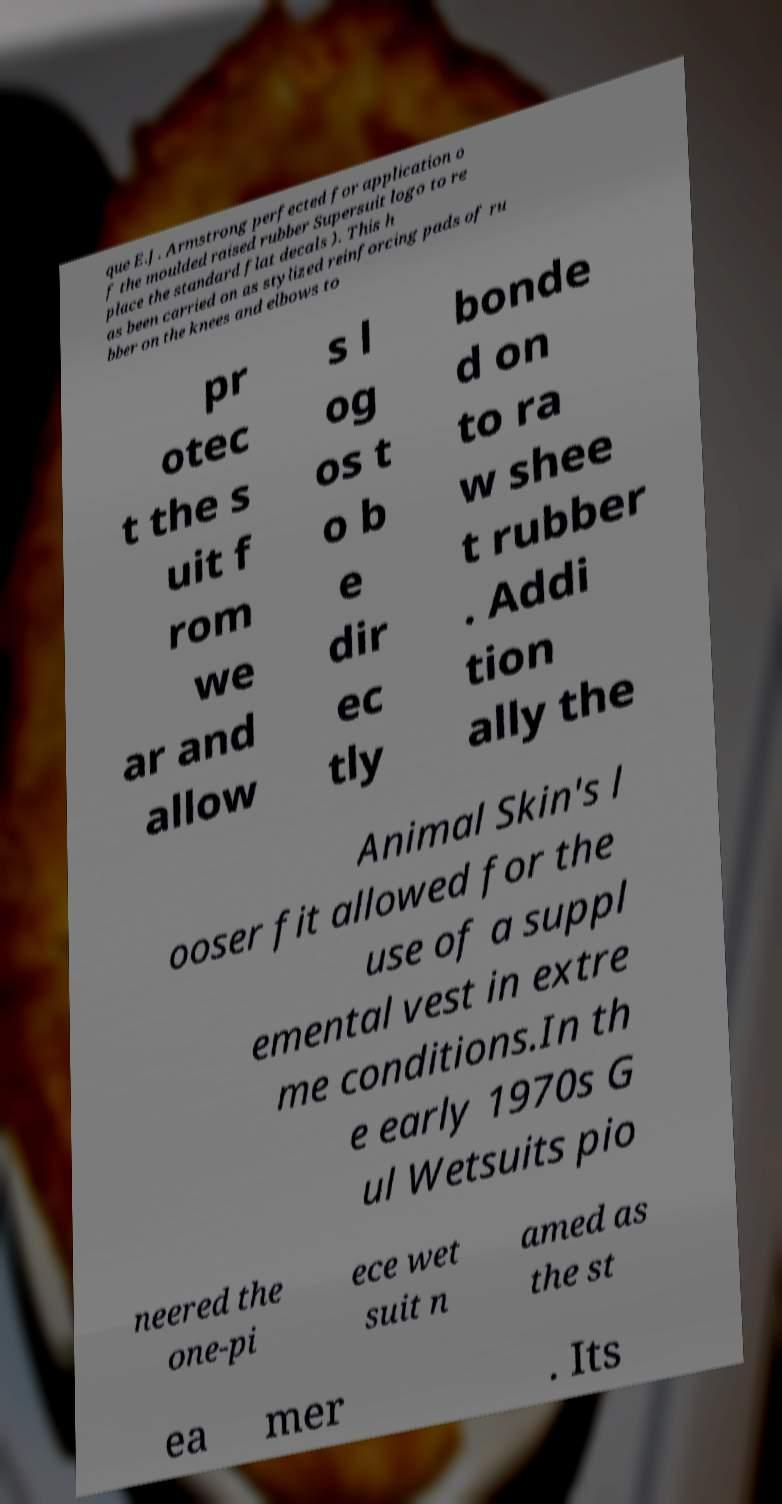I need the written content from this picture converted into text. Can you do that? que E.J. Armstrong perfected for application o f the moulded raised rubber Supersuit logo to re place the standard flat decals ). This h as been carried on as stylized reinforcing pads of ru bber on the knees and elbows to pr otec t the s uit f rom we ar and allow s l og os t o b e dir ec tly bonde d on to ra w shee t rubber . Addi tion ally the Animal Skin's l ooser fit allowed for the use of a suppl emental vest in extre me conditions.In th e early 1970s G ul Wetsuits pio neered the one-pi ece wet suit n amed as the st ea mer . Its 